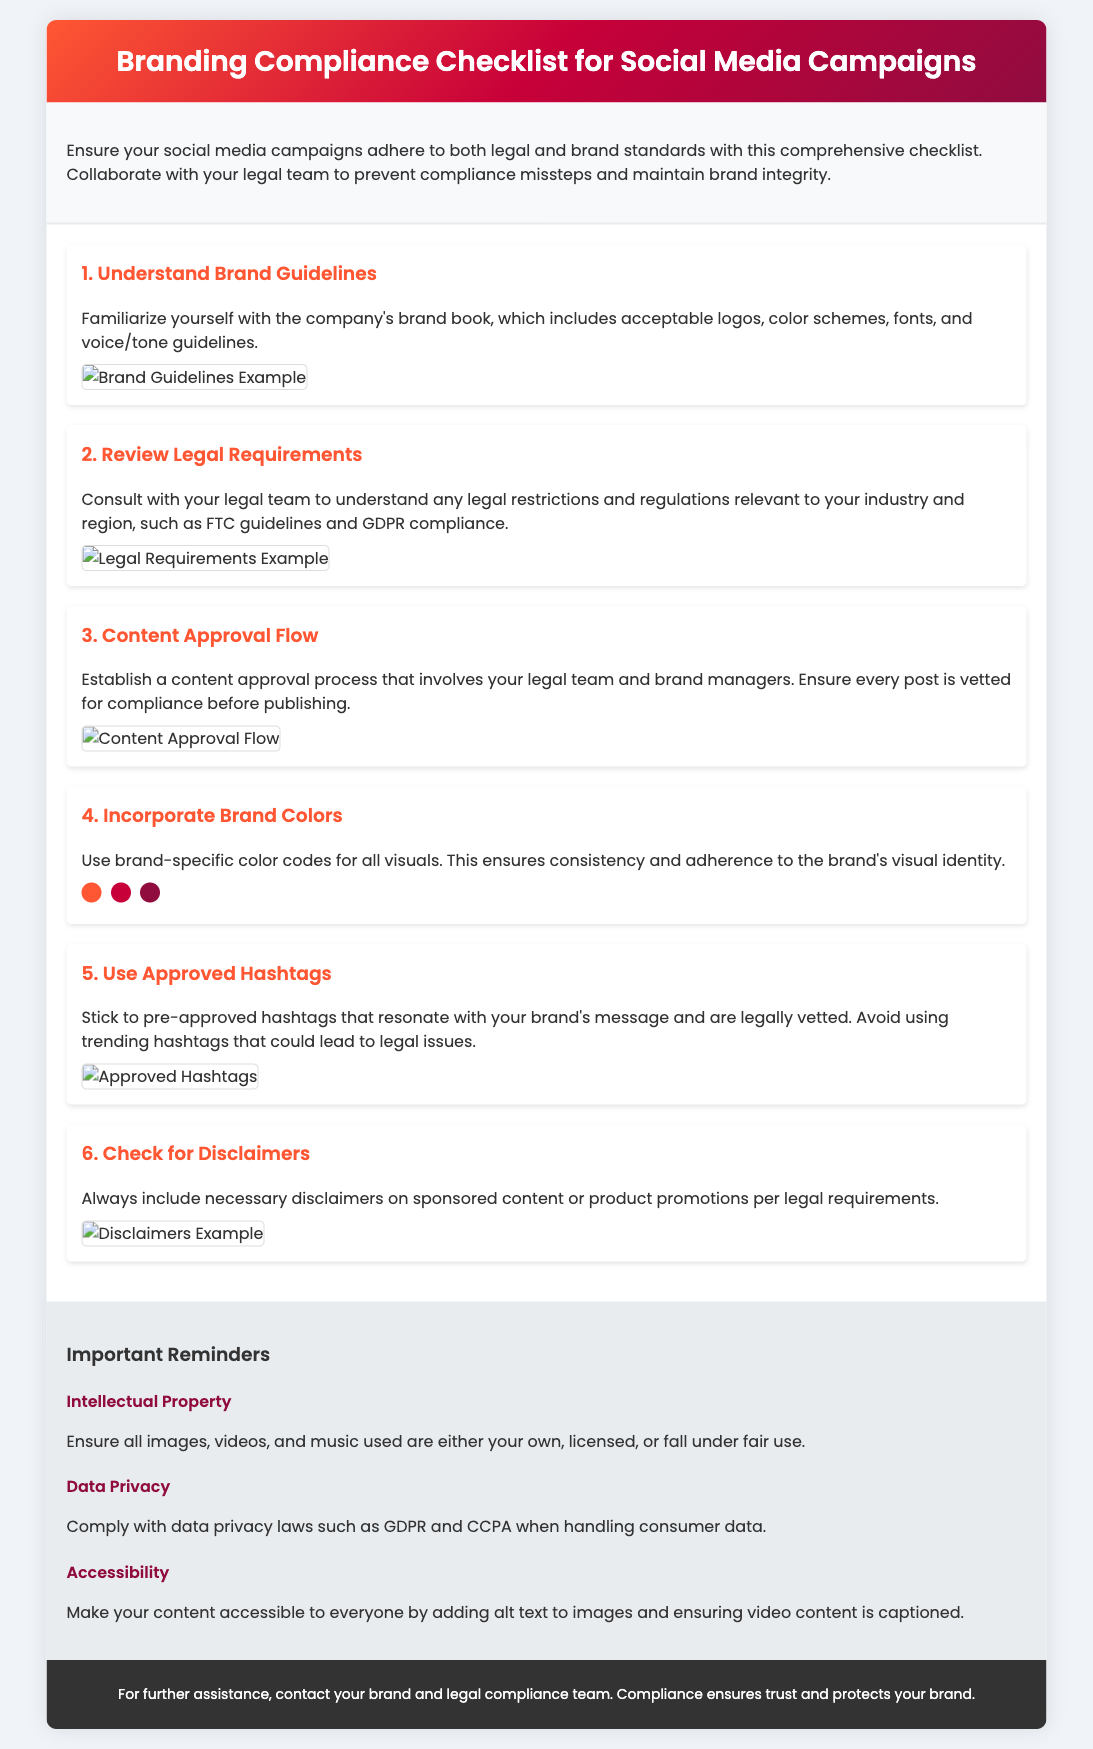What is the title of the document? The title of the document is found in the header section, which indicates the main topic being addressed.
Answer: Branding Compliance Checklist for Social Media Campaigns How many steps are listed in the checklist? The number of steps in the checklist is determined by counting each individual step throughout the document.
Answer: 6 What is the color scheme used in the header? The color scheme used in the header can be identified by looking at the gradient colors specified in the CSS styling for that section.
Answer: #FF5733, #C70039, #900C3F Which team should be consulted regarding legal requirements? The appropriate team for legal inquiries is mentioned in the context of reviewing legal standards and compliance in social media campaigns.
Answer: Legal team What should always be included on sponsored content? The specific requirement for sponsored content refers to essential legal specifications needed on promotional posts, which ensures transparency and compliance.
Answer: Necessary disclaimers What is the main reason to adopt a content approval process? The reasoning behind this process is to ensure compliance with both legal and branding guidelines, as outlined in the respective section of the document.
Answer: Compliance What type of content must have alt text added? The document specifies a requirement for accessibility in regards to a specific type of content that needs additional description for clarity.
Answer: Images What are the highlighted brand color codes provided? The color codes displayed are meant to ensure brand consistency, and they can be found in the section discussing the incorporation of brand colors.
Answer: #FF5733, #C70039, #900C3F 